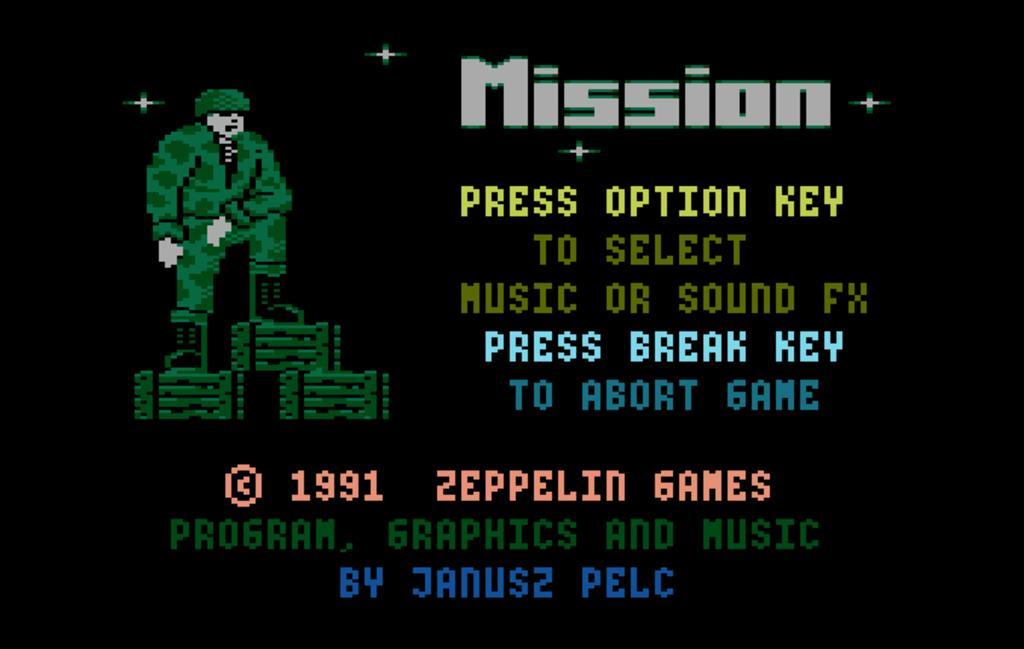In one or two sentences, can you explain what this image depicts? In this image we can see a poster with text, and image on it. 